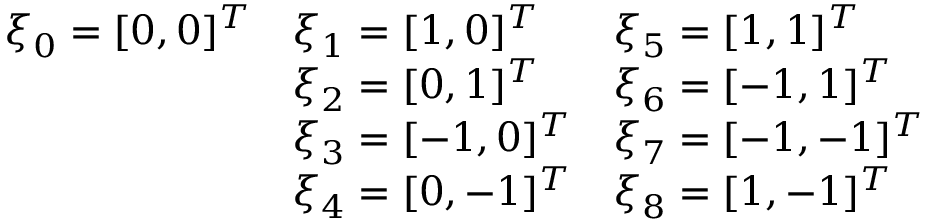Convert formula to latex. <formula><loc_0><loc_0><loc_500><loc_500>\begin{array} { l l l } { \xi _ { 0 } = [ 0 , 0 ] ^ { T } } & { \xi _ { 1 } = [ 1 , 0 ] ^ { T } } & { \xi _ { 5 } = [ 1 , 1 ] ^ { T } } \\ & { \xi _ { 2 } = [ 0 , 1 ] ^ { T } } & { \xi _ { 6 } = [ - 1 , 1 ] ^ { T } } \\ & { \xi _ { 3 } = [ - 1 , 0 ] ^ { T } } & { \xi _ { 7 } = [ - 1 , - 1 ] ^ { T } } \\ & { \xi _ { 4 } = [ 0 , - 1 ] ^ { T } } & { \xi _ { 8 } = [ 1 , - 1 ] ^ { T } } \end{array}</formula> 